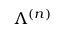Convert formula to latex. <formula><loc_0><loc_0><loc_500><loc_500>\Lambda ^ { ( n ) }</formula> 